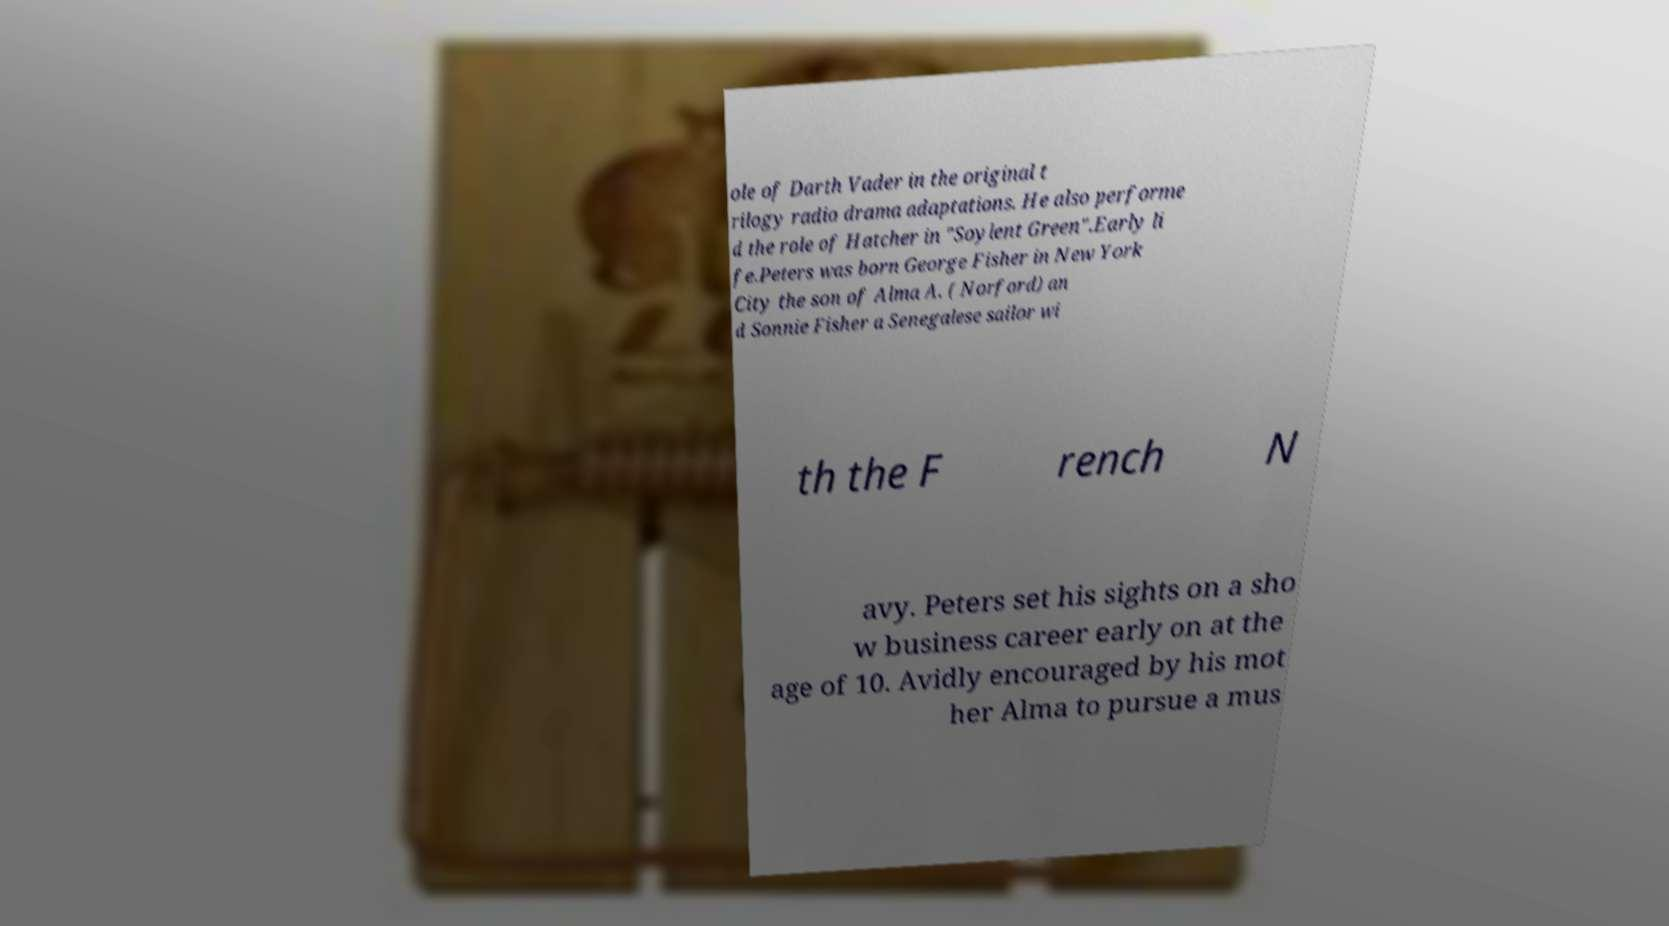Can you read and provide the text displayed in the image?This photo seems to have some interesting text. Can you extract and type it out for me? ole of Darth Vader in the original t rilogy radio drama adaptations. He also performe d the role of Hatcher in "Soylent Green".Early li fe.Peters was born George Fisher in New York City the son of Alma A. ( Norford) an d Sonnie Fisher a Senegalese sailor wi th the F rench N avy. Peters set his sights on a sho w business career early on at the age of 10. Avidly encouraged by his mot her Alma to pursue a mus 